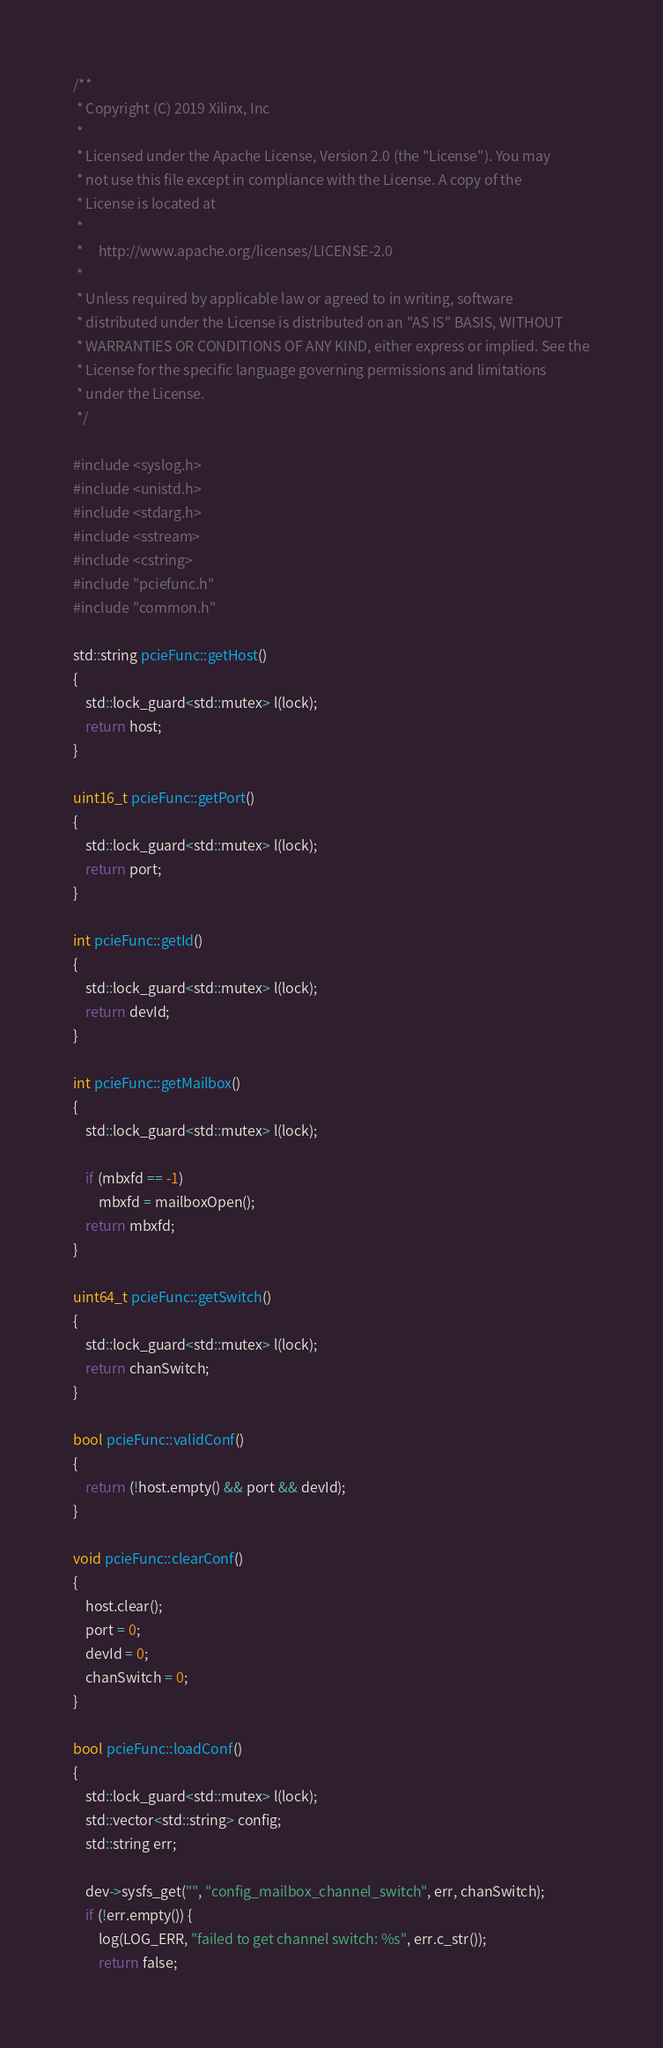<code> <loc_0><loc_0><loc_500><loc_500><_C++_>/**
 * Copyright (C) 2019 Xilinx, Inc
 *
 * Licensed under the Apache License, Version 2.0 (the "License"). You may
 * not use this file except in compliance with the License. A copy of the
 * License is located at
 *
 *     http://www.apache.org/licenses/LICENSE-2.0
 *
 * Unless required by applicable law or agreed to in writing, software
 * distributed under the License is distributed on an "AS IS" BASIS, WITHOUT
 * WARRANTIES OR CONDITIONS OF ANY KIND, either express or implied. See the
 * License for the specific language governing permissions and limitations
 * under the License.
 */

#include <syslog.h>
#include <unistd.h>
#include <stdarg.h>
#include <sstream>
#include <cstring>
#include "pciefunc.h"
#include "common.h"

std::string pcieFunc::getHost()
{
    std::lock_guard<std::mutex> l(lock);
    return host;
}

uint16_t pcieFunc::getPort()
{
    std::lock_guard<std::mutex> l(lock);
    return port;
}

int pcieFunc::getId()
{
    std::lock_guard<std::mutex> l(lock);
    return devId;
}

int pcieFunc::getMailbox()
{
    std::lock_guard<std::mutex> l(lock);

    if (mbxfd == -1)
        mbxfd = mailboxOpen();
    return mbxfd;
}

uint64_t pcieFunc::getSwitch()
{
    std::lock_guard<std::mutex> l(lock);
    return chanSwitch;
}

bool pcieFunc::validConf()
{
    return (!host.empty() && port && devId);
}

void pcieFunc::clearConf()
{
    host.clear();
    port = 0;
    devId = 0;
    chanSwitch = 0;
}

bool pcieFunc::loadConf()
{
    std::lock_guard<std::mutex> l(lock);
    std::vector<std::string> config;
    std::string err;

    dev->sysfs_get("", "config_mailbox_channel_switch", err, chanSwitch);
    if (!err.empty()) {
        log(LOG_ERR, "failed to get channel switch: %s", err.c_str());
        return false;</code> 